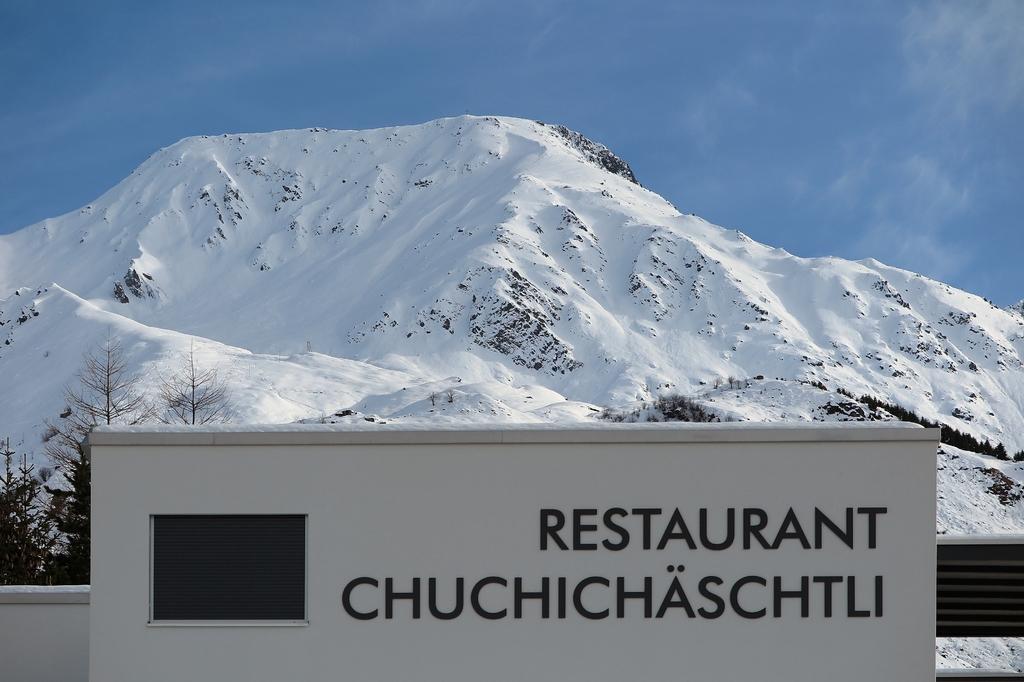What kind of establishment is this?
Offer a very short reply. Restaurant. Where is this resaurant located?
Ensure brevity in your answer.  Chuchichaschtli. 